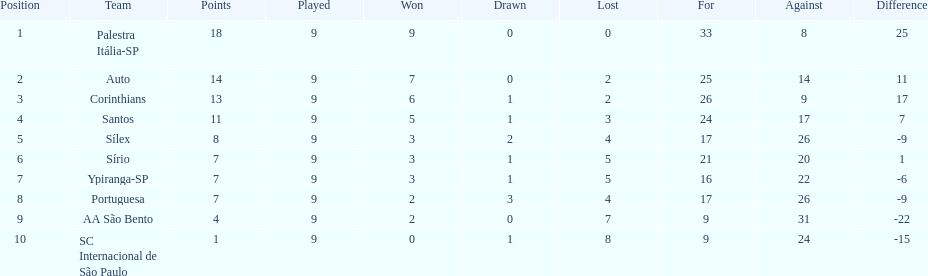Which team achieved the maximum points? Palestra Itália-SP. 